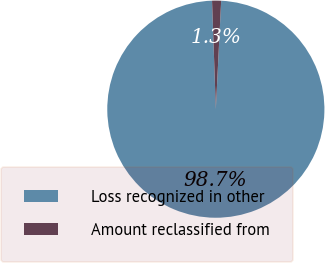Convert chart to OTSL. <chart><loc_0><loc_0><loc_500><loc_500><pie_chart><fcel>Loss recognized in other<fcel>Amount reclassified from<nl><fcel>98.66%<fcel>1.34%<nl></chart> 